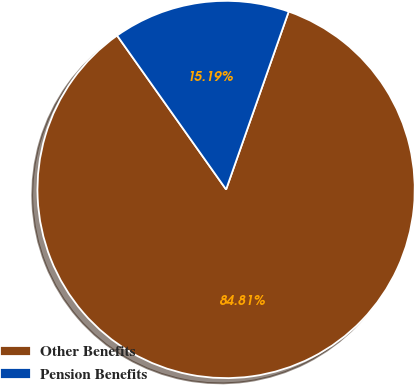Convert chart. <chart><loc_0><loc_0><loc_500><loc_500><pie_chart><fcel>Other Benefits<fcel>Pension Benefits<nl><fcel>84.81%<fcel>15.19%<nl></chart> 